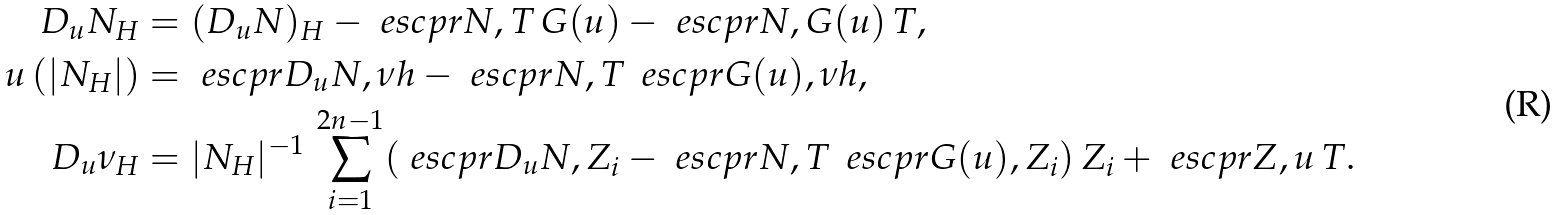<formula> <loc_0><loc_0><loc_500><loc_500>D _ { u } N _ { H } & = ( D _ { u } N ) _ { H } - \ e s c p r { N , T } \, G ( u ) - \ e s c p r { N , G ( u ) } \, T , \\ u \, ( | N _ { H } | ) & = \ e s c p r { D _ { u } N , \nu h } - \ e s c p r { N , T } \, \ e s c p r { G ( u ) , \nu h } , \\ D _ { u } \nu _ { H } & = | N _ { H } | ^ { - 1 } \, \sum _ { i = 1 } ^ { 2 n - 1 } ( \ e s c p r { D _ { u } N , Z _ { i } } - \ e s c p r { N , T } \, \ e s c p r { G ( u ) , Z _ { i } } ) \, Z _ { i } + \ e s c p r { Z , u } \, T .</formula> 